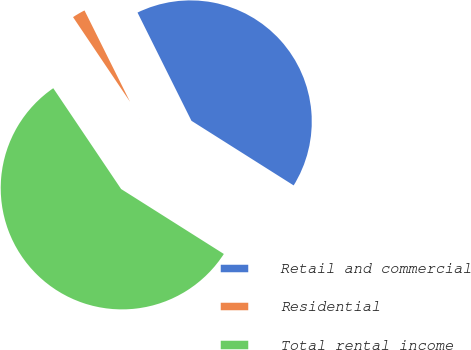<chart> <loc_0><loc_0><loc_500><loc_500><pie_chart><fcel>Retail and commercial<fcel>Residential<fcel>Total rental income<nl><fcel>41.33%<fcel>2.07%<fcel>56.6%<nl></chart> 